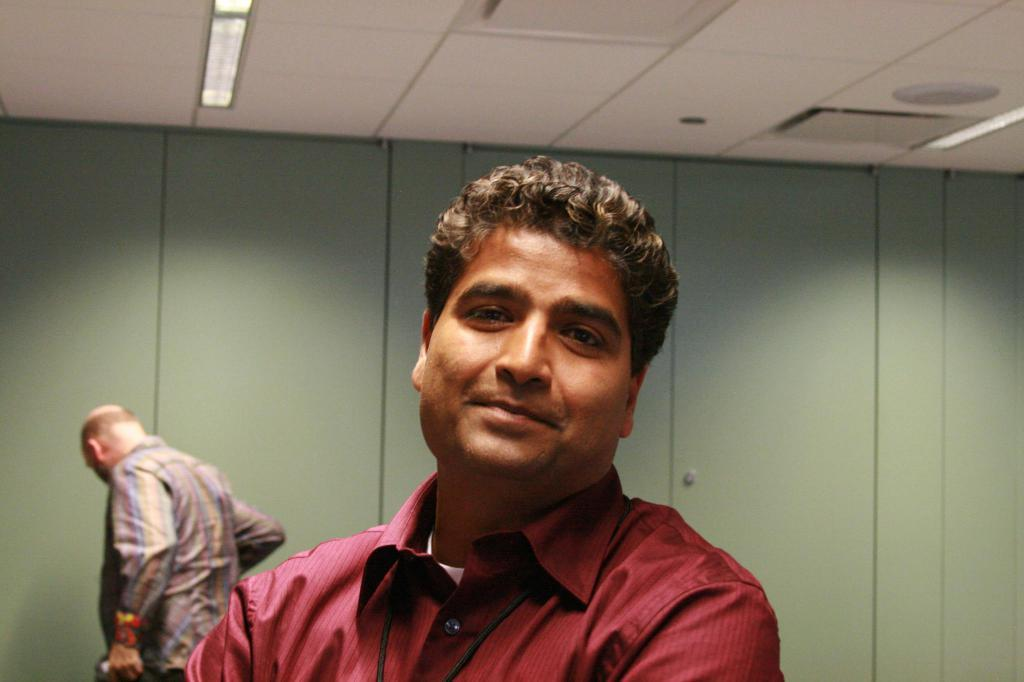Who is present in the image? There is a man in the image. Can you describe the background of the image? There is another man in the background of the image, along with doors and lights on the ceiling. What type of brush is the man using to paint the veil in the image? There is no brush, painting, or veil present in the image. 